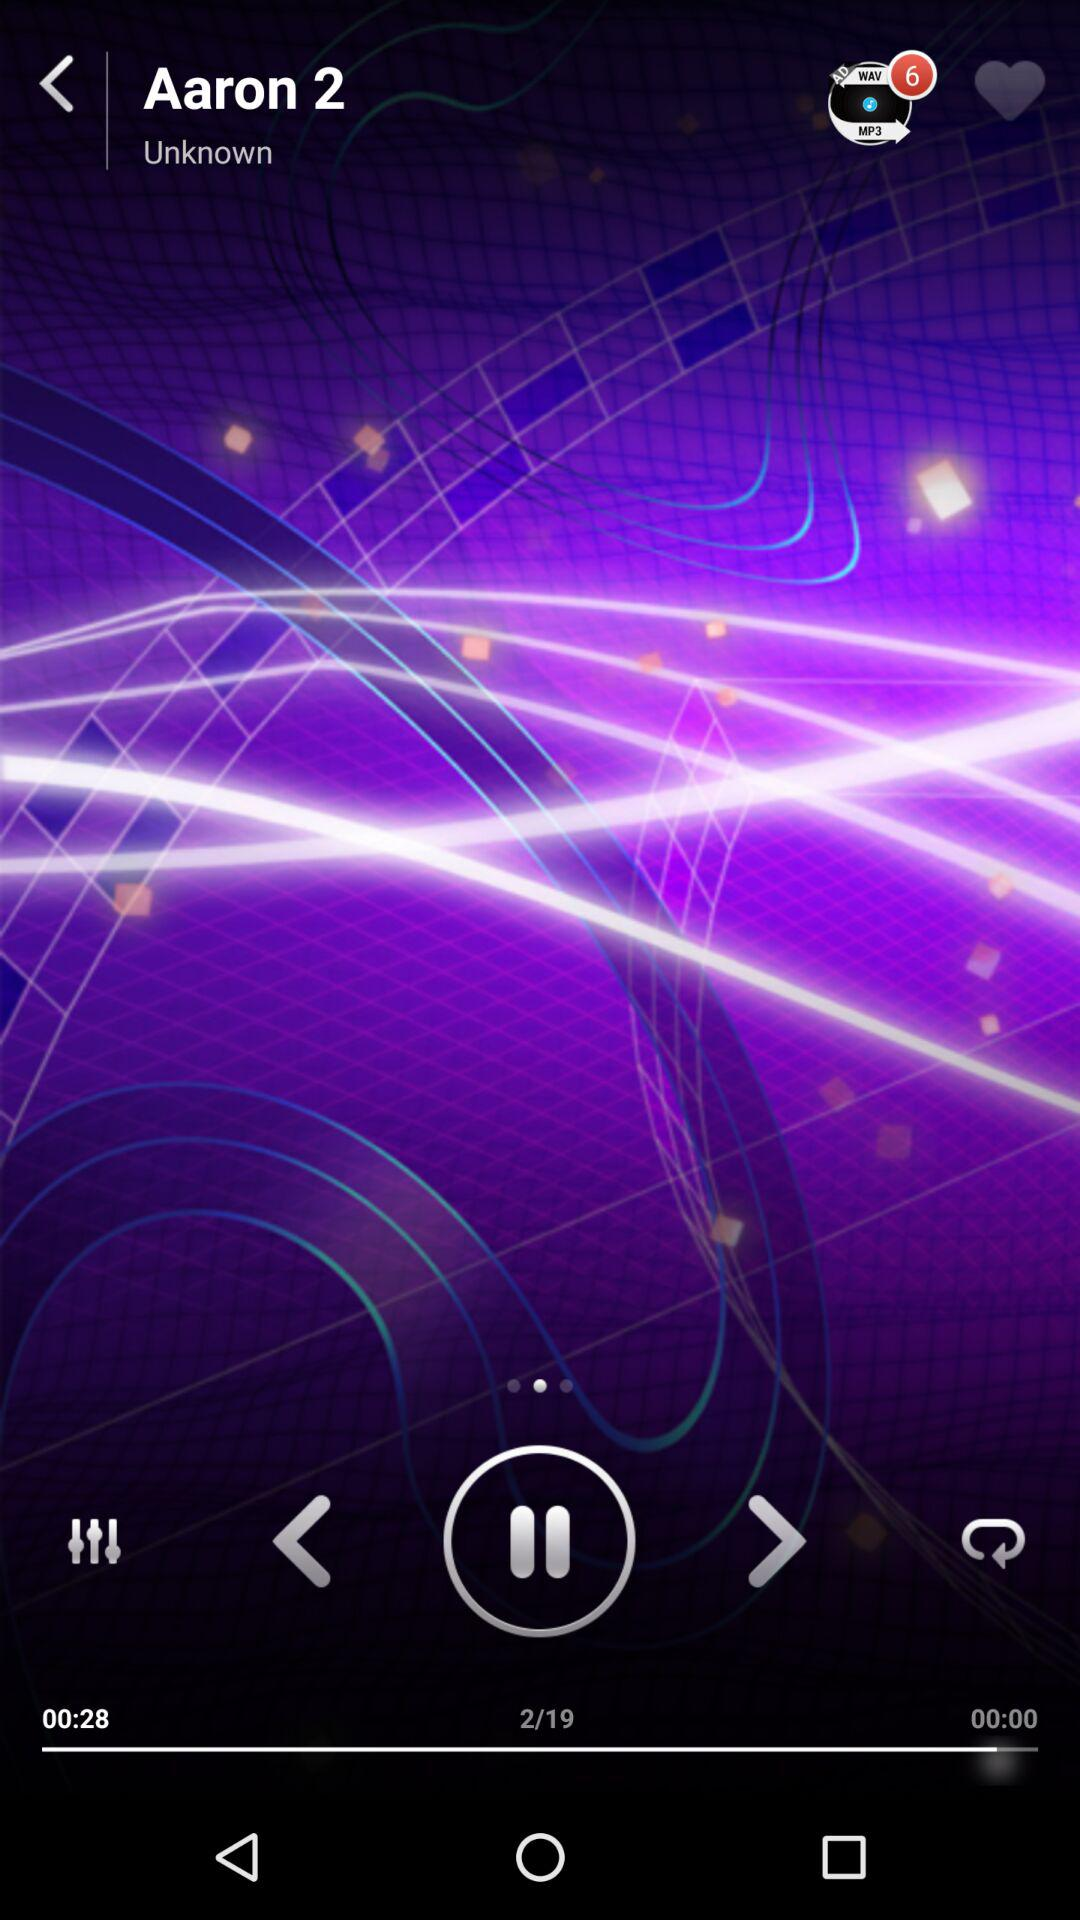What is the total number of songs in a queue?
When the provided information is insufficient, respond with <no answer>. <no answer> 